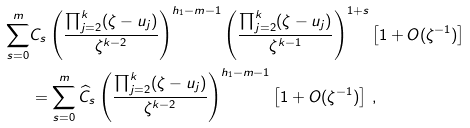<formula> <loc_0><loc_0><loc_500><loc_500>\sum _ { s = 0 } ^ { m } & C _ { s } \left ( \frac { \prod _ { j = 2 } ^ { k } ( \zeta - u _ { j } ) } { \zeta ^ { k - 2 } } \right ) ^ { h _ { 1 } - m - 1 } \left ( \frac { \prod _ { j = 2 } ^ { k } ( \zeta - u _ { j } ) } { \zeta ^ { k - 1 } } \right ) ^ { 1 + s } \left [ 1 + O ( \zeta ^ { - 1 } ) \right ] \\ & = \sum _ { s = 0 } ^ { m } \widehat { C } _ { s } \left ( \frac { \prod _ { j = 2 } ^ { k } ( \zeta - u _ { j } ) } { \zeta ^ { k - 2 } } \right ) ^ { h _ { 1 } - m - 1 } \left [ 1 + O ( \zeta ^ { - 1 } ) \right ] \, ,</formula> 